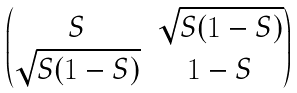Convert formula to latex. <formula><loc_0><loc_0><loc_500><loc_500>\begin{pmatrix} S & \sqrt { S ( 1 - S ) } \\ \sqrt { S ( 1 - S ) } & 1 - S \end{pmatrix}</formula> 